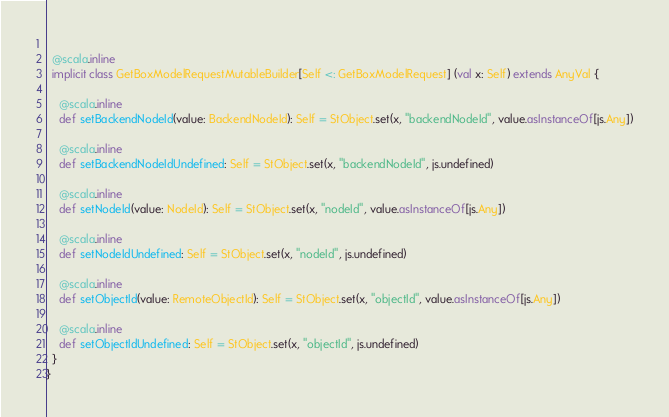<code> <loc_0><loc_0><loc_500><loc_500><_Scala_>  
  @scala.inline
  implicit class GetBoxModelRequestMutableBuilder[Self <: GetBoxModelRequest] (val x: Self) extends AnyVal {
    
    @scala.inline
    def setBackendNodeId(value: BackendNodeId): Self = StObject.set(x, "backendNodeId", value.asInstanceOf[js.Any])
    
    @scala.inline
    def setBackendNodeIdUndefined: Self = StObject.set(x, "backendNodeId", js.undefined)
    
    @scala.inline
    def setNodeId(value: NodeId): Self = StObject.set(x, "nodeId", value.asInstanceOf[js.Any])
    
    @scala.inline
    def setNodeIdUndefined: Self = StObject.set(x, "nodeId", js.undefined)
    
    @scala.inline
    def setObjectId(value: RemoteObjectId): Self = StObject.set(x, "objectId", value.asInstanceOf[js.Any])
    
    @scala.inline
    def setObjectIdUndefined: Self = StObject.set(x, "objectId", js.undefined)
  }
}
</code> 